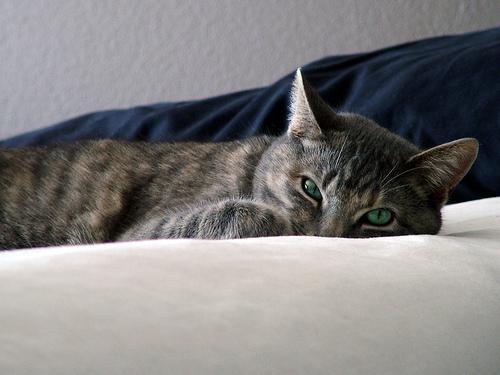How many cats are on the bed?
Give a very brief answer. 1. 